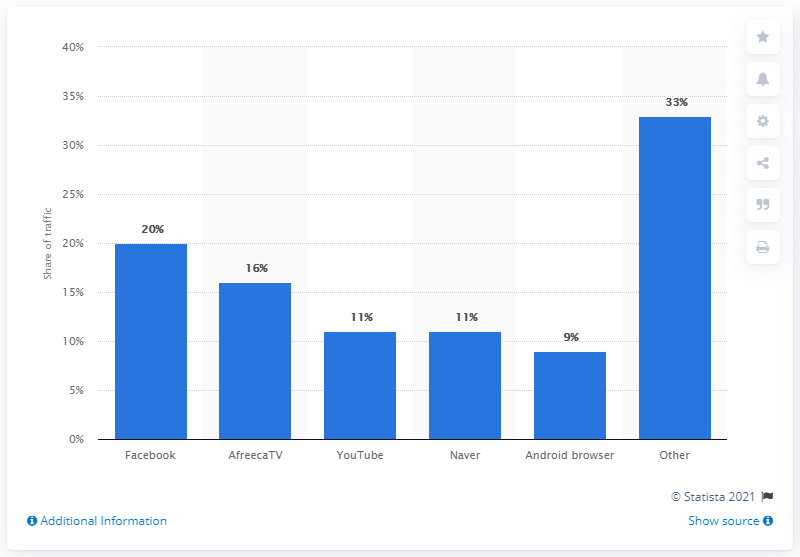Highlight a few significant elements in this photo. According to data, Facebook accounted for 20 percent of all mobile app traffic. 